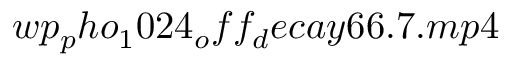Convert formula to latex. <formula><loc_0><loc_0><loc_500><loc_500>w p _ { p } h o _ { 1 } 0 2 4 _ { o } f f _ { d } e c a y 6 6 . 7 . m p 4</formula> 